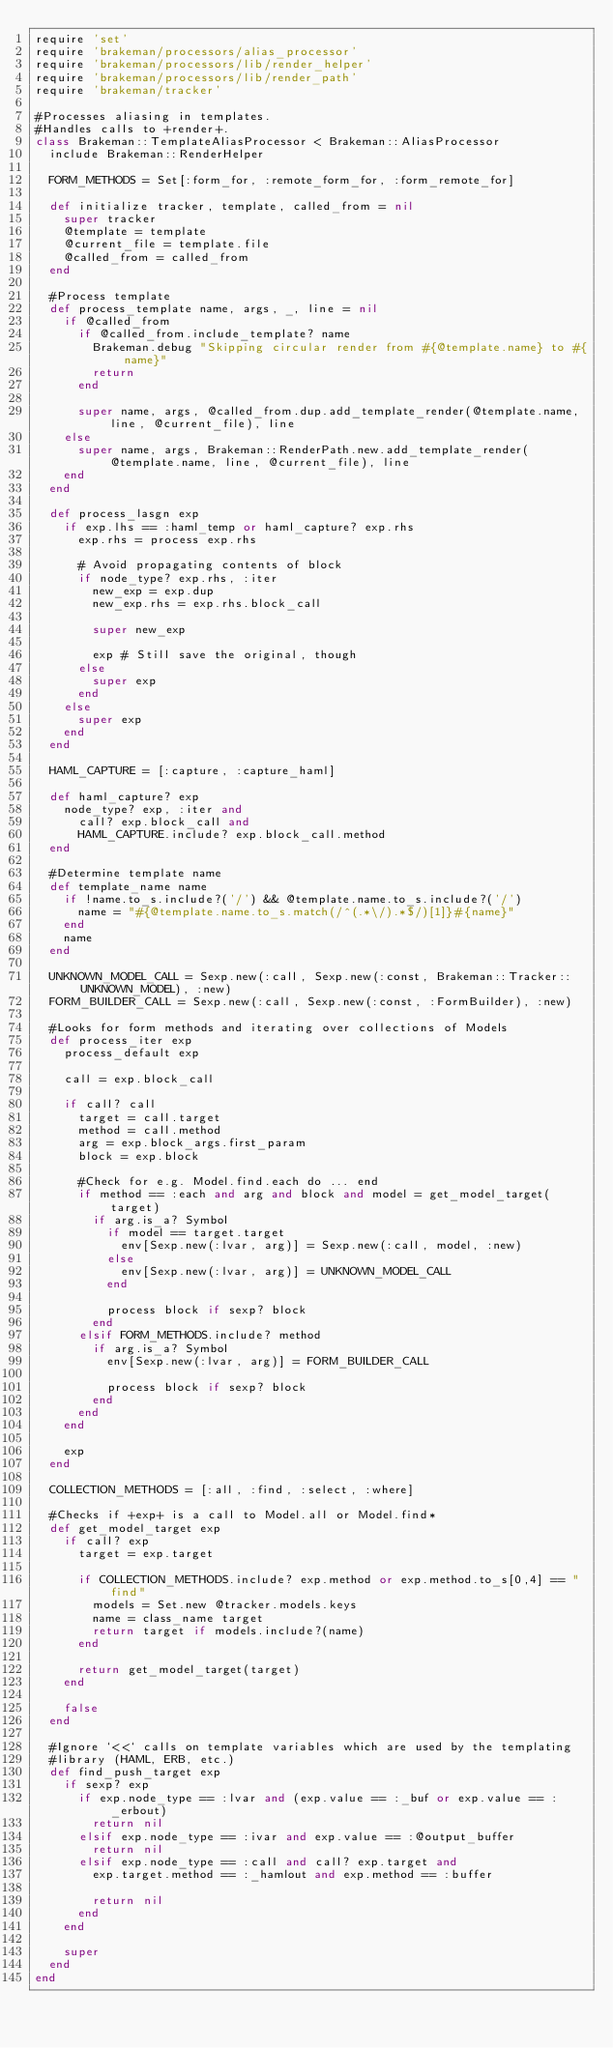<code> <loc_0><loc_0><loc_500><loc_500><_Ruby_>require 'set'
require 'brakeman/processors/alias_processor'
require 'brakeman/processors/lib/render_helper'
require 'brakeman/processors/lib/render_path'
require 'brakeman/tracker'

#Processes aliasing in templates.
#Handles calls to +render+.
class Brakeman::TemplateAliasProcessor < Brakeman::AliasProcessor
  include Brakeman::RenderHelper

  FORM_METHODS = Set[:form_for, :remote_form_for, :form_remote_for]

  def initialize tracker, template, called_from = nil
    super tracker
    @template = template
    @current_file = template.file
    @called_from = called_from
  end

  #Process template
  def process_template name, args, _, line = nil
    if @called_from
      if @called_from.include_template? name
        Brakeman.debug "Skipping circular render from #{@template.name} to #{name}"
        return
      end

      super name, args, @called_from.dup.add_template_render(@template.name, line, @current_file), line
    else
      super name, args, Brakeman::RenderPath.new.add_template_render(@template.name, line, @current_file), line
    end
  end

  def process_lasgn exp
    if exp.lhs == :haml_temp or haml_capture? exp.rhs
      exp.rhs = process exp.rhs

      # Avoid propagating contents of block
      if node_type? exp.rhs, :iter
        new_exp = exp.dup
        new_exp.rhs = exp.rhs.block_call

        super new_exp

        exp # Still save the original, though
      else
        super exp
      end
    else
      super exp
    end
  end

  HAML_CAPTURE = [:capture, :capture_haml]

  def haml_capture? exp
    node_type? exp, :iter and
      call? exp.block_call and
      HAML_CAPTURE.include? exp.block_call.method
  end

  #Determine template name
  def template_name name
    if !name.to_s.include?('/') && @template.name.to_s.include?('/')
      name = "#{@template.name.to_s.match(/^(.*\/).*$/)[1]}#{name}"
    end
    name
  end

  UNKNOWN_MODEL_CALL = Sexp.new(:call, Sexp.new(:const, Brakeman::Tracker::UNKNOWN_MODEL), :new)
  FORM_BUILDER_CALL = Sexp.new(:call, Sexp.new(:const, :FormBuilder), :new)

  #Looks for form methods and iterating over collections of Models
  def process_iter exp
    process_default exp

    call = exp.block_call

    if call? call
      target = call.target
      method = call.method
      arg = exp.block_args.first_param
      block = exp.block

      #Check for e.g. Model.find.each do ... end
      if method == :each and arg and block and model = get_model_target(target)
        if arg.is_a? Symbol
          if model == target.target
            env[Sexp.new(:lvar, arg)] = Sexp.new(:call, model, :new)
          else
            env[Sexp.new(:lvar, arg)] = UNKNOWN_MODEL_CALL
          end

          process block if sexp? block
        end
      elsif FORM_METHODS.include? method
        if arg.is_a? Symbol
          env[Sexp.new(:lvar, arg)] = FORM_BUILDER_CALL

          process block if sexp? block
        end
      end
    end

    exp
  end

  COLLECTION_METHODS = [:all, :find, :select, :where]

  #Checks if +exp+ is a call to Model.all or Model.find*
  def get_model_target exp
    if call? exp
      target = exp.target

      if COLLECTION_METHODS.include? exp.method or exp.method.to_s[0,4] == "find"
        models = Set.new @tracker.models.keys
        name = class_name target
        return target if models.include?(name)
      end

      return get_model_target(target)
    end

    false
  end

  #Ignore `<<` calls on template variables which are used by the templating
  #library (HAML, ERB, etc.)
  def find_push_target exp
    if sexp? exp
      if exp.node_type == :lvar and (exp.value == :_buf or exp.value == :_erbout)
        return nil
      elsif exp.node_type == :ivar and exp.value == :@output_buffer
        return nil
      elsif exp.node_type == :call and call? exp.target and
        exp.target.method == :_hamlout and exp.method == :buffer

        return nil
      end
    end

    super
  end
end
</code> 